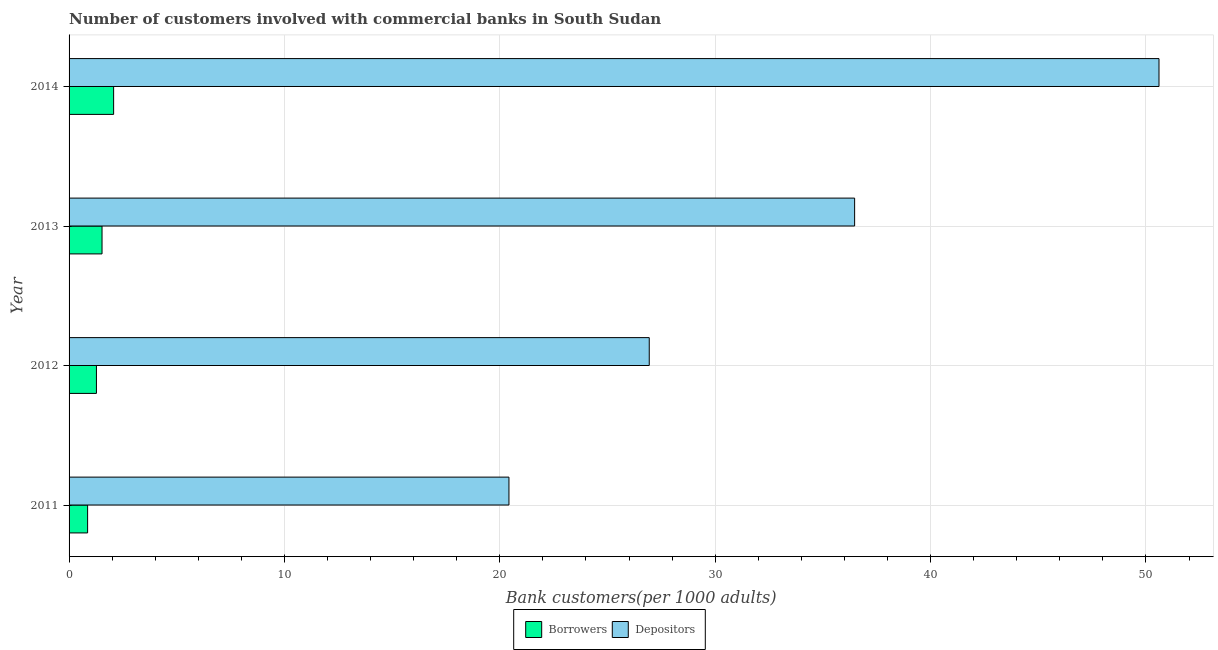How many different coloured bars are there?
Offer a very short reply. 2. How many groups of bars are there?
Give a very brief answer. 4. Are the number of bars per tick equal to the number of legend labels?
Offer a terse response. Yes. In how many cases, is the number of bars for a given year not equal to the number of legend labels?
Your answer should be very brief. 0. What is the number of borrowers in 2012?
Offer a very short reply. 1.27. Across all years, what is the maximum number of borrowers?
Provide a succinct answer. 2.07. Across all years, what is the minimum number of borrowers?
Your answer should be very brief. 0.86. In which year was the number of depositors minimum?
Give a very brief answer. 2011. What is the total number of depositors in the graph?
Your answer should be very brief. 134.44. What is the difference between the number of borrowers in 2012 and that in 2013?
Provide a succinct answer. -0.26. What is the difference between the number of depositors in 2012 and the number of borrowers in 2013?
Your response must be concise. 25.41. What is the average number of borrowers per year?
Your answer should be compact. 1.43. In the year 2014, what is the difference between the number of borrowers and number of depositors?
Give a very brief answer. -48.54. In how many years, is the number of borrowers greater than 14 ?
Provide a short and direct response. 0. What is the ratio of the number of depositors in 2011 to that in 2013?
Offer a very short reply. 0.56. What is the difference between the highest and the second highest number of borrowers?
Your answer should be very brief. 0.54. What is the difference between the highest and the lowest number of borrowers?
Make the answer very short. 1.21. Is the sum of the number of borrowers in 2011 and 2014 greater than the maximum number of depositors across all years?
Your answer should be very brief. No. What does the 1st bar from the top in 2013 represents?
Ensure brevity in your answer.  Depositors. What does the 2nd bar from the bottom in 2013 represents?
Provide a succinct answer. Depositors. How many bars are there?
Give a very brief answer. 8. How many years are there in the graph?
Provide a short and direct response. 4. What is the difference between two consecutive major ticks on the X-axis?
Provide a short and direct response. 10. How many legend labels are there?
Your answer should be very brief. 2. What is the title of the graph?
Give a very brief answer. Number of customers involved with commercial banks in South Sudan. What is the label or title of the X-axis?
Give a very brief answer. Bank customers(per 1000 adults). What is the Bank customers(per 1000 adults) of Borrowers in 2011?
Give a very brief answer. 0.86. What is the Bank customers(per 1000 adults) in Depositors in 2011?
Offer a terse response. 20.42. What is the Bank customers(per 1000 adults) in Borrowers in 2012?
Your answer should be compact. 1.27. What is the Bank customers(per 1000 adults) of Depositors in 2012?
Make the answer very short. 26.94. What is the Bank customers(per 1000 adults) of Borrowers in 2013?
Provide a succinct answer. 1.53. What is the Bank customers(per 1000 adults) of Depositors in 2013?
Ensure brevity in your answer.  36.47. What is the Bank customers(per 1000 adults) of Borrowers in 2014?
Offer a terse response. 2.07. What is the Bank customers(per 1000 adults) of Depositors in 2014?
Ensure brevity in your answer.  50.61. Across all years, what is the maximum Bank customers(per 1000 adults) in Borrowers?
Give a very brief answer. 2.07. Across all years, what is the maximum Bank customers(per 1000 adults) of Depositors?
Give a very brief answer. 50.61. Across all years, what is the minimum Bank customers(per 1000 adults) of Borrowers?
Keep it short and to the point. 0.86. Across all years, what is the minimum Bank customers(per 1000 adults) of Depositors?
Provide a short and direct response. 20.42. What is the total Bank customers(per 1000 adults) in Borrowers in the graph?
Offer a very short reply. 5.73. What is the total Bank customers(per 1000 adults) of Depositors in the graph?
Offer a very short reply. 134.44. What is the difference between the Bank customers(per 1000 adults) in Borrowers in 2011 and that in 2012?
Your response must be concise. -0.41. What is the difference between the Bank customers(per 1000 adults) in Depositors in 2011 and that in 2012?
Provide a short and direct response. -6.51. What is the difference between the Bank customers(per 1000 adults) of Borrowers in 2011 and that in 2013?
Your response must be concise. -0.67. What is the difference between the Bank customers(per 1000 adults) of Depositors in 2011 and that in 2013?
Provide a short and direct response. -16.05. What is the difference between the Bank customers(per 1000 adults) in Borrowers in 2011 and that in 2014?
Offer a very short reply. -1.21. What is the difference between the Bank customers(per 1000 adults) of Depositors in 2011 and that in 2014?
Give a very brief answer. -30.18. What is the difference between the Bank customers(per 1000 adults) in Borrowers in 2012 and that in 2013?
Give a very brief answer. -0.26. What is the difference between the Bank customers(per 1000 adults) of Depositors in 2012 and that in 2013?
Make the answer very short. -9.54. What is the difference between the Bank customers(per 1000 adults) in Borrowers in 2012 and that in 2014?
Your answer should be compact. -0.8. What is the difference between the Bank customers(per 1000 adults) in Depositors in 2012 and that in 2014?
Provide a short and direct response. -23.67. What is the difference between the Bank customers(per 1000 adults) of Borrowers in 2013 and that in 2014?
Your answer should be very brief. -0.54. What is the difference between the Bank customers(per 1000 adults) in Depositors in 2013 and that in 2014?
Provide a succinct answer. -14.13. What is the difference between the Bank customers(per 1000 adults) in Borrowers in 2011 and the Bank customers(per 1000 adults) in Depositors in 2012?
Offer a terse response. -26.08. What is the difference between the Bank customers(per 1000 adults) in Borrowers in 2011 and the Bank customers(per 1000 adults) in Depositors in 2013?
Ensure brevity in your answer.  -35.61. What is the difference between the Bank customers(per 1000 adults) in Borrowers in 2011 and the Bank customers(per 1000 adults) in Depositors in 2014?
Your response must be concise. -49.75. What is the difference between the Bank customers(per 1000 adults) in Borrowers in 2012 and the Bank customers(per 1000 adults) in Depositors in 2013?
Provide a short and direct response. -35.2. What is the difference between the Bank customers(per 1000 adults) of Borrowers in 2012 and the Bank customers(per 1000 adults) of Depositors in 2014?
Offer a very short reply. -49.34. What is the difference between the Bank customers(per 1000 adults) in Borrowers in 2013 and the Bank customers(per 1000 adults) in Depositors in 2014?
Provide a succinct answer. -49.08. What is the average Bank customers(per 1000 adults) in Borrowers per year?
Ensure brevity in your answer.  1.43. What is the average Bank customers(per 1000 adults) of Depositors per year?
Your answer should be compact. 33.61. In the year 2011, what is the difference between the Bank customers(per 1000 adults) in Borrowers and Bank customers(per 1000 adults) in Depositors?
Ensure brevity in your answer.  -19.56. In the year 2012, what is the difference between the Bank customers(per 1000 adults) of Borrowers and Bank customers(per 1000 adults) of Depositors?
Offer a terse response. -25.67. In the year 2013, what is the difference between the Bank customers(per 1000 adults) in Borrowers and Bank customers(per 1000 adults) in Depositors?
Your response must be concise. -34.94. In the year 2014, what is the difference between the Bank customers(per 1000 adults) in Borrowers and Bank customers(per 1000 adults) in Depositors?
Your answer should be very brief. -48.54. What is the ratio of the Bank customers(per 1000 adults) in Borrowers in 2011 to that in 2012?
Offer a terse response. 0.68. What is the ratio of the Bank customers(per 1000 adults) in Depositors in 2011 to that in 2012?
Your answer should be very brief. 0.76. What is the ratio of the Bank customers(per 1000 adults) in Borrowers in 2011 to that in 2013?
Provide a succinct answer. 0.56. What is the ratio of the Bank customers(per 1000 adults) of Depositors in 2011 to that in 2013?
Offer a terse response. 0.56. What is the ratio of the Bank customers(per 1000 adults) in Borrowers in 2011 to that in 2014?
Your answer should be very brief. 0.42. What is the ratio of the Bank customers(per 1000 adults) in Depositors in 2011 to that in 2014?
Keep it short and to the point. 0.4. What is the ratio of the Bank customers(per 1000 adults) in Borrowers in 2012 to that in 2013?
Your answer should be compact. 0.83. What is the ratio of the Bank customers(per 1000 adults) in Depositors in 2012 to that in 2013?
Make the answer very short. 0.74. What is the ratio of the Bank customers(per 1000 adults) in Borrowers in 2012 to that in 2014?
Offer a terse response. 0.61. What is the ratio of the Bank customers(per 1000 adults) in Depositors in 2012 to that in 2014?
Your answer should be compact. 0.53. What is the ratio of the Bank customers(per 1000 adults) of Borrowers in 2013 to that in 2014?
Give a very brief answer. 0.74. What is the ratio of the Bank customers(per 1000 adults) of Depositors in 2013 to that in 2014?
Your answer should be compact. 0.72. What is the difference between the highest and the second highest Bank customers(per 1000 adults) of Borrowers?
Your answer should be very brief. 0.54. What is the difference between the highest and the second highest Bank customers(per 1000 adults) in Depositors?
Offer a very short reply. 14.13. What is the difference between the highest and the lowest Bank customers(per 1000 adults) in Borrowers?
Give a very brief answer. 1.21. What is the difference between the highest and the lowest Bank customers(per 1000 adults) in Depositors?
Offer a terse response. 30.18. 